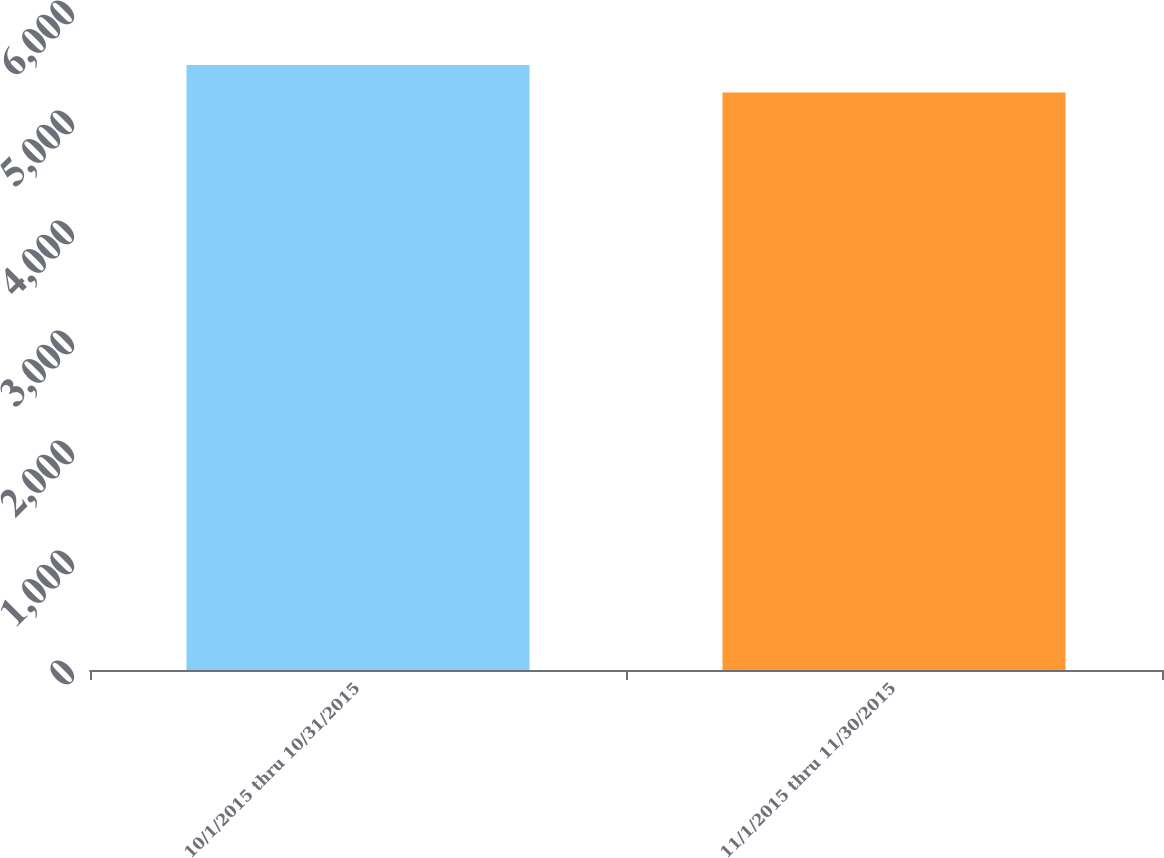Convert chart. <chart><loc_0><loc_0><loc_500><loc_500><bar_chart><fcel>10/1/2015 thru 10/31/2015<fcel>11/1/2015 thru 11/30/2015<nl><fcel>5500<fcel>5250<nl></chart> 